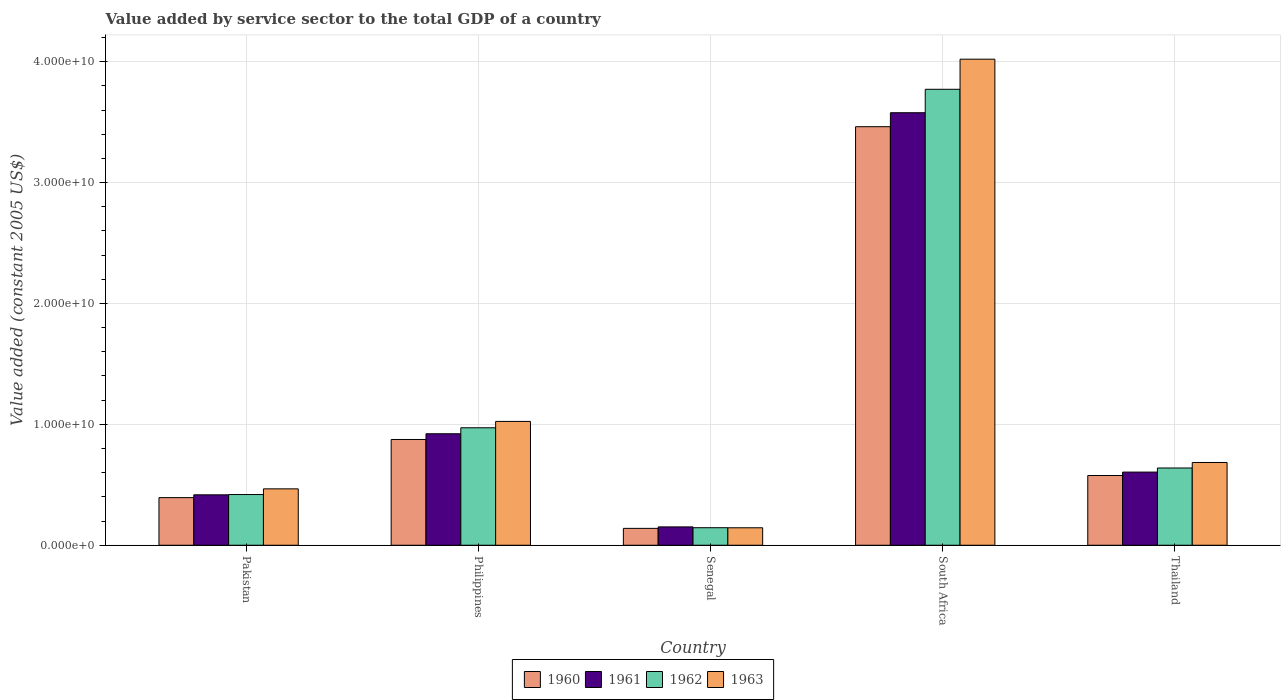Are the number of bars per tick equal to the number of legend labels?
Ensure brevity in your answer.  Yes. How many bars are there on the 4th tick from the left?
Your answer should be very brief. 4. How many bars are there on the 1st tick from the right?
Provide a succinct answer. 4. What is the label of the 5th group of bars from the left?
Offer a terse response. Thailand. In how many cases, is the number of bars for a given country not equal to the number of legend labels?
Ensure brevity in your answer.  0. What is the value added by service sector in 1962 in South Africa?
Provide a succinct answer. 3.77e+1. Across all countries, what is the maximum value added by service sector in 1961?
Give a very brief answer. 3.58e+1. Across all countries, what is the minimum value added by service sector in 1963?
Your answer should be very brief. 1.44e+09. In which country was the value added by service sector in 1960 maximum?
Your response must be concise. South Africa. In which country was the value added by service sector in 1963 minimum?
Make the answer very short. Senegal. What is the total value added by service sector in 1963 in the graph?
Offer a very short reply. 6.34e+1. What is the difference between the value added by service sector in 1962 in Philippines and that in Senegal?
Your answer should be very brief. 8.27e+09. What is the difference between the value added by service sector in 1963 in Pakistan and the value added by service sector in 1960 in South Africa?
Keep it short and to the point. -3.00e+1. What is the average value added by service sector in 1960 per country?
Your answer should be very brief. 1.09e+1. What is the difference between the value added by service sector of/in 1960 and value added by service sector of/in 1963 in Philippines?
Your response must be concise. -1.49e+09. What is the ratio of the value added by service sector in 1963 in Pakistan to that in Senegal?
Your response must be concise. 3.23. Is the difference between the value added by service sector in 1960 in Senegal and South Africa greater than the difference between the value added by service sector in 1963 in Senegal and South Africa?
Your answer should be very brief. Yes. What is the difference between the highest and the second highest value added by service sector in 1962?
Ensure brevity in your answer.  -2.80e+1. What is the difference between the highest and the lowest value added by service sector in 1962?
Ensure brevity in your answer.  3.63e+1. In how many countries, is the value added by service sector in 1962 greater than the average value added by service sector in 1962 taken over all countries?
Make the answer very short. 1. Is the sum of the value added by service sector in 1960 in Pakistan and Thailand greater than the maximum value added by service sector in 1962 across all countries?
Your answer should be compact. No. What does the 2nd bar from the left in Philippines represents?
Your response must be concise. 1961. Is it the case that in every country, the sum of the value added by service sector in 1961 and value added by service sector in 1963 is greater than the value added by service sector in 1962?
Make the answer very short. Yes. How many countries are there in the graph?
Make the answer very short. 5. Where does the legend appear in the graph?
Your answer should be compact. Bottom center. How many legend labels are there?
Keep it short and to the point. 4. What is the title of the graph?
Ensure brevity in your answer.  Value added by service sector to the total GDP of a country. Does "1971" appear as one of the legend labels in the graph?
Provide a succinct answer. No. What is the label or title of the X-axis?
Provide a short and direct response. Country. What is the label or title of the Y-axis?
Provide a succinct answer. Value added (constant 2005 US$). What is the Value added (constant 2005 US$) of 1960 in Pakistan?
Your response must be concise. 3.94e+09. What is the Value added (constant 2005 US$) of 1961 in Pakistan?
Give a very brief answer. 4.17e+09. What is the Value added (constant 2005 US$) of 1962 in Pakistan?
Your response must be concise. 4.19e+09. What is the Value added (constant 2005 US$) in 1963 in Pakistan?
Provide a short and direct response. 4.66e+09. What is the Value added (constant 2005 US$) of 1960 in Philippines?
Offer a very short reply. 8.75e+09. What is the Value added (constant 2005 US$) of 1961 in Philippines?
Your response must be concise. 9.22e+09. What is the Value added (constant 2005 US$) of 1962 in Philippines?
Your response must be concise. 9.72e+09. What is the Value added (constant 2005 US$) of 1963 in Philippines?
Make the answer very short. 1.02e+1. What is the Value added (constant 2005 US$) in 1960 in Senegal?
Provide a short and direct response. 1.39e+09. What is the Value added (constant 2005 US$) in 1961 in Senegal?
Your answer should be compact. 1.52e+09. What is the Value added (constant 2005 US$) in 1962 in Senegal?
Your answer should be compact. 1.45e+09. What is the Value added (constant 2005 US$) of 1963 in Senegal?
Keep it short and to the point. 1.44e+09. What is the Value added (constant 2005 US$) in 1960 in South Africa?
Make the answer very short. 3.46e+1. What is the Value added (constant 2005 US$) of 1961 in South Africa?
Give a very brief answer. 3.58e+1. What is the Value added (constant 2005 US$) of 1962 in South Africa?
Offer a terse response. 3.77e+1. What is the Value added (constant 2005 US$) in 1963 in South Africa?
Keep it short and to the point. 4.02e+1. What is the Value added (constant 2005 US$) of 1960 in Thailand?
Provide a short and direct response. 5.77e+09. What is the Value added (constant 2005 US$) of 1961 in Thailand?
Your response must be concise. 6.05e+09. What is the Value added (constant 2005 US$) of 1962 in Thailand?
Your answer should be compact. 6.39e+09. What is the Value added (constant 2005 US$) of 1963 in Thailand?
Offer a terse response. 6.84e+09. Across all countries, what is the maximum Value added (constant 2005 US$) of 1960?
Your answer should be very brief. 3.46e+1. Across all countries, what is the maximum Value added (constant 2005 US$) of 1961?
Your response must be concise. 3.58e+1. Across all countries, what is the maximum Value added (constant 2005 US$) of 1962?
Provide a succinct answer. 3.77e+1. Across all countries, what is the maximum Value added (constant 2005 US$) of 1963?
Ensure brevity in your answer.  4.02e+1. Across all countries, what is the minimum Value added (constant 2005 US$) in 1960?
Your answer should be very brief. 1.39e+09. Across all countries, what is the minimum Value added (constant 2005 US$) in 1961?
Make the answer very short. 1.52e+09. Across all countries, what is the minimum Value added (constant 2005 US$) of 1962?
Ensure brevity in your answer.  1.45e+09. Across all countries, what is the minimum Value added (constant 2005 US$) of 1963?
Offer a terse response. 1.44e+09. What is the total Value added (constant 2005 US$) in 1960 in the graph?
Your answer should be compact. 5.45e+1. What is the total Value added (constant 2005 US$) of 1961 in the graph?
Your answer should be very brief. 5.67e+1. What is the total Value added (constant 2005 US$) of 1962 in the graph?
Your answer should be compact. 5.95e+1. What is the total Value added (constant 2005 US$) of 1963 in the graph?
Ensure brevity in your answer.  6.34e+1. What is the difference between the Value added (constant 2005 US$) of 1960 in Pakistan and that in Philippines?
Your response must be concise. -4.81e+09. What is the difference between the Value added (constant 2005 US$) of 1961 in Pakistan and that in Philippines?
Offer a terse response. -5.05e+09. What is the difference between the Value added (constant 2005 US$) of 1962 in Pakistan and that in Philippines?
Provide a short and direct response. -5.52e+09. What is the difference between the Value added (constant 2005 US$) in 1963 in Pakistan and that in Philippines?
Provide a succinct answer. -5.58e+09. What is the difference between the Value added (constant 2005 US$) in 1960 in Pakistan and that in Senegal?
Ensure brevity in your answer.  2.54e+09. What is the difference between the Value added (constant 2005 US$) in 1961 in Pakistan and that in Senegal?
Your answer should be compact. 2.65e+09. What is the difference between the Value added (constant 2005 US$) of 1962 in Pakistan and that in Senegal?
Give a very brief answer. 2.74e+09. What is the difference between the Value added (constant 2005 US$) of 1963 in Pakistan and that in Senegal?
Give a very brief answer. 3.22e+09. What is the difference between the Value added (constant 2005 US$) in 1960 in Pakistan and that in South Africa?
Offer a very short reply. -3.07e+1. What is the difference between the Value added (constant 2005 US$) of 1961 in Pakistan and that in South Africa?
Make the answer very short. -3.16e+1. What is the difference between the Value added (constant 2005 US$) of 1962 in Pakistan and that in South Africa?
Ensure brevity in your answer.  -3.35e+1. What is the difference between the Value added (constant 2005 US$) of 1963 in Pakistan and that in South Africa?
Offer a very short reply. -3.55e+1. What is the difference between the Value added (constant 2005 US$) in 1960 in Pakistan and that in Thailand?
Provide a short and direct response. -1.83e+09. What is the difference between the Value added (constant 2005 US$) in 1961 in Pakistan and that in Thailand?
Your answer should be compact. -1.88e+09. What is the difference between the Value added (constant 2005 US$) of 1962 in Pakistan and that in Thailand?
Ensure brevity in your answer.  -2.20e+09. What is the difference between the Value added (constant 2005 US$) in 1963 in Pakistan and that in Thailand?
Ensure brevity in your answer.  -2.18e+09. What is the difference between the Value added (constant 2005 US$) of 1960 in Philippines and that in Senegal?
Provide a succinct answer. 7.35e+09. What is the difference between the Value added (constant 2005 US$) of 1961 in Philippines and that in Senegal?
Keep it short and to the point. 7.70e+09. What is the difference between the Value added (constant 2005 US$) of 1962 in Philippines and that in Senegal?
Offer a very short reply. 8.27e+09. What is the difference between the Value added (constant 2005 US$) of 1963 in Philippines and that in Senegal?
Keep it short and to the point. 8.80e+09. What is the difference between the Value added (constant 2005 US$) of 1960 in Philippines and that in South Africa?
Your response must be concise. -2.59e+1. What is the difference between the Value added (constant 2005 US$) in 1961 in Philippines and that in South Africa?
Your answer should be compact. -2.66e+1. What is the difference between the Value added (constant 2005 US$) of 1962 in Philippines and that in South Africa?
Offer a terse response. -2.80e+1. What is the difference between the Value added (constant 2005 US$) of 1963 in Philippines and that in South Africa?
Give a very brief answer. -3.00e+1. What is the difference between the Value added (constant 2005 US$) of 1960 in Philippines and that in Thailand?
Keep it short and to the point. 2.98e+09. What is the difference between the Value added (constant 2005 US$) of 1961 in Philippines and that in Thailand?
Offer a very short reply. 3.17e+09. What is the difference between the Value added (constant 2005 US$) in 1962 in Philippines and that in Thailand?
Keep it short and to the point. 3.33e+09. What is the difference between the Value added (constant 2005 US$) of 1963 in Philippines and that in Thailand?
Offer a terse response. 3.40e+09. What is the difference between the Value added (constant 2005 US$) in 1960 in Senegal and that in South Africa?
Make the answer very short. -3.32e+1. What is the difference between the Value added (constant 2005 US$) of 1961 in Senegal and that in South Africa?
Make the answer very short. -3.43e+1. What is the difference between the Value added (constant 2005 US$) of 1962 in Senegal and that in South Africa?
Provide a short and direct response. -3.63e+1. What is the difference between the Value added (constant 2005 US$) of 1963 in Senegal and that in South Africa?
Your answer should be very brief. -3.88e+1. What is the difference between the Value added (constant 2005 US$) of 1960 in Senegal and that in Thailand?
Ensure brevity in your answer.  -4.37e+09. What is the difference between the Value added (constant 2005 US$) in 1961 in Senegal and that in Thailand?
Keep it short and to the point. -4.53e+09. What is the difference between the Value added (constant 2005 US$) in 1962 in Senegal and that in Thailand?
Provide a short and direct response. -4.94e+09. What is the difference between the Value added (constant 2005 US$) in 1963 in Senegal and that in Thailand?
Ensure brevity in your answer.  -5.40e+09. What is the difference between the Value added (constant 2005 US$) of 1960 in South Africa and that in Thailand?
Offer a terse response. 2.89e+1. What is the difference between the Value added (constant 2005 US$) in 1961 in South Africa and that in Thailand?
Offer a terse response. 2.97e+1. What is the difference between the Value added (constant 2005 US$) in 1962 in South Africa and that in Thailand?
Offer a terse response. 3.13e+1. What is the difference between the Value added (constant 2005 US$) of 1963 in South Africa and that in Thailand?
Offer a very short reply. 3.34e+1. What is the difference between the Value added (constant 2005 US$) in 1960 in Pakistan and the Value added (constant 2005 US$) in 1961 in Philippines?
Give a very brief answer. -5.28e+09. What is the difference between the Value added (constant 2005 US$) of 1960 in Pakistan and the Value added (constant 2005 US$) of 1962 in Philippines?
Provide a succinct answer. -5.78e+09. What is the difference between the Value added (constant 2005 US$) of 1960 in Pakistan and the Value added (constant 2005 US$) of 1963 in Philippines?
Ensure brevity in your answer.  -6.30e+09. What is the difference between the Value added (constant 2005 US$) of 1961 in Pakistan and the Value added (constant 2005 US$) of 1962 in Philippines?
Provide a short and direct response. -5.55e+09. What is the difference between the Value added (constant 2005 US$) in 1961 in Pakistan and the Value added (constant 2005 US$) in 1963 in Philippines?
Your response must be concise. -6.07e+09. What is the difference between the Value added (constant 2005 US$) of 1962 in Pakistan and the Value added (constant 2005 US$) of 1963 in Philippines?
Your response must be concise. -6.05e+09. What is the difference between the Value added (constant 2005 US$) in 1960 in Pakistan and the Value added (constant 2005 US$) in 1961 in Senegal?
Offer a terse response. 2.42e+09. What is the difference between the Value added (constant 2005 US$) in 1960 in Pakistan and the Value added (constant 2005 US$) in 1962 in Senegal?
Provide a succinct answer. 2.49e+09. What is the difference between the Value added (constant 2005 US$) in 1960 in Pakistan and the Value added (constant 2005 US$) in 1963 in Senegal?
Provide a succinct answer. 2.49e+09. What is the difference between the Value added (constant 2005 US$) of 1961 in Pakistan and the Value added (constant 2005 US$) of 1962 in Senegal?
Ensure brevity in your answer.  2.72e+09. What is the difference between the Value added (constant 2005 US$) in 1961 in Pakistan and the Value added (constant 2005 US$) in 1963 in Senegal?
Offer a terse response. 2.73e+09. What is the difference between the Value added (constant 2005 US$) in 1962 in Pakistan and the Value added (constant 2005 US$) in 1963 in Senegal?
Provide a succinct answer. 2.75e+09. What is the difference between the Value added (constant 2005 US$) of 1960 in Pakistan and the Value added (constant 2005 US$) of 1961 in South Africa?
Your answer should be very brief. -3.18e+1. What is the difference between the Value added (constant 2005 US$) in 1960 in Pakistan and the Value added (constant 2005 US$) in 1962 in South Africa?
Keep it short and to the point. -3.38e+1. What is the difference between the Value added (constant 2005 US$) in 1960 in Pakistan and the Value added (constant 2005 US$) in 1963 in South Africa?
Give a very brief answer. -3.63e+1. What is the difference between the Value added (constant 2005 US$) in 1961 in Pakistan and the Value added (constant 2005 US$) in 1962 in South Africa?
Your response must be concise. -3.35e+1. What is the difference between the Value added (constant 2005 US$) of 1961 in Pakistan and the Value added (constant 2005 US$) of 1963 in South Africa?
Ensure brevity in your answer.  -3.60e+1. What is the difference between the Value added (constant 2005 US$) of 1962 in Pakistan and the Value added (constant 2005 US$) of 1963 in South Africa?
Give a very brief answer. -3.60e+1. What is the difference between the Value added (constant 2005 US$) of 1960 in Pakistan and the Value added (constant 2005 US$) of 1961 in Thailand?
Ensure brevity in your answer.  -2.11e+09. What is the difference between the Value added (constant 2005 US$) in 1960 in Pakistan and the Value added (constant 2005 US$) in 1962 in Thailand?
Provide a short and direct response. -2.45e+09. What is the difference between the Value added (constant 2005 US$) of 1960 in Pakistan and the Value added (constant 2005 US$) of 1963 in Thailand?
Your answer should be very brief. -2.91e+09. What is the difference between the Value added (constant 2005 US$) of 1961 in Pakistan and the Value added (constant 2005 US$) of 1962 in Thailand?
Ensure brevity in your answer.  -2.22e+09. What is the difference between the Value added (constant 2005 US$) in 1961 in Pakistan and the Value added (constant 2005 US$) in 1963 in Thailand?
Provide a short and direct response. -2.67e+09. What is the difference between the Value added (constant 2005 US$) of 1962 in Pakistan and the Value added (constant 2005 US$) of 1963 in Thailand?
Your response must be concise. -2.65e+09. What is the difference between the Value added (constant 2005 US$) in 1960 in Philippines and the Value added (constant 2005 US$) in 1961 in Senegal?
Provide a succinct answer. 7.23e+09. What is the difference between the Value added (constant 2005 US$) of 1960 in Philippines and the Value added (constant 2005 US$) of 1962 in Senegal?
Your answer should be compact. 7.30e+09. What is the difference between the Value added (constant 2005 US$) in 1960 in Philippines and the Value added (constant 2005 US$) in 1963 in Senegal?
Ensure brevity in your answer.  7.30e+09. What is the difference between the Value added (constant 2005 US$) in 1961 in Philippines and the Value added (constant 2005 US$) in 1962 in Senegal?
Offer a very short reply. 7.77e+09. What is the difference between the Value added (constant 2005 US$) in 1961 in Philippines and the Value added (constant 2005 US$) in 1963 in Senegal?
Provide a short and direct response. 7.78e+09. What is the difference between the Value added (constant 2005 US$) in 1962 in Philippines and the Value added (constant 2005 US$) in 1963 in Senegal?
Keep it short and to the point. 8.27e+09. What is the difference between the Value added (constant 2005 US$) in 1960 in Philippines and the Value added (constant 2005 US$) in 1961 in South Africa?
Your answer should be compact. -2.70e+1. What is the difference between the Value added (constant 2005 US$) of 1960 in Philippines and the Value added (constant 2005 US$) of 1962 in South Africa?
Your response must be concise. -2.90e+1. What is the difference between the Value added (constant 2005 US$) in 1960 in Philippines and the Value added (constant 2005 US$) in 1963 in South Africa?
Keep it short and to the point. -3.15e+1. What is the difference between the Value added (constant 2005 US$) of 1961 in Philippines and the Value added (constant 2005 US$) of 1962 in South Africa?
Your response must be concise. -2.85e+1. What is the difference between the Value added (constant 2005 US$) in 1961 in Philippines and the Value added (constant 2005 US$) in 1963 in South Africa?
Offer a very short reply. -3.10e+1. What is the difference between the Value added (constant 2005 US$) of 1962 in Philippines and the Value added (constant 2005 US$) of 1963 in South Africa?
Keep it short and to the point. -3.05e+1. What is the difference between the Value added (constant 2005 US$) of 1960 in Philippines and the Value added (constant 2005 US$) of 1961 in Thailand?
Offer a very short reply. 2.70e+09. What is the difference between the Value added (constant 2005 US$) of 1960 in Philippines and the Value added (constant 2005 US$) of 1962 in Thailand?
Offer a terse response. 2.36e+09. What is the difference between the Value added (constant 2005 US$) of 1960 in Philippines and the Value added (constant 2005 US$) of 1963 in Thailand?
Your response must be concise. 1.90e+09. What is the difference between the Value added (constant 2005 US$) of 1961 in Philippines and the Value added (constant 2005 US$) of 1962 in Thailand?
Offer a terse response. 2.83e+09. What is the difference between the Value added (constant 2005 US$) in 1961 in Philippines and the Value added (constant 2005 US$) in 1963 in Thailand?
Your response must be concise. 2.38e+09. What is the difference between the Value added (constant 2005 US$) in 1962 in Philippines and the Value added (constant 2005 US$) in 1963 in Thailand?
Provide a short and direct response. 2.87e+09. What is the difference between the Value added (constant 2005 US$) of 1960 in Senegal and the Value added (constant 2005 US$) of 1961 in South Africa?
Your response must be concise. -3.44e+1. What is the difference between the Value added (constant 2005 US$) of 1960 in Senegal and the Value added (constant 2005 US$) of 1962 in South Africa?
Provide a short and direct response. -3.63e+1. What is the difference between the Value added (constant 2005 US$) in 1960 in Senegal and the Value added (constant 2005 US$) in 1963 in South Africa?
Your answer should be very brief. -3.88e+1. What is the difference between the Value added (constant 2005 US$) in 1961 in Senegal and the Value added (constant 2005 US$) in 1962 in South Africa?
Provide a short and direct response. -3.62e+1. What is the difference between the Value added (constant 2005 US$) of 1961 in Senegal and the Value added (constant 2005 US$) of 1963 in South Africa?
Your response must be concise. -3.87e+1. What is the difference between the Value added (constant 2005 US$) of 1962 in Senegal and the Value added (constant 2005 US$) of 1963 in South Africa?
Offer a terse response. -3.88e+1. What is the difference between the Value added (constant 2005 US$) in 1960 in Senegal and the Value added (constant 2005 US$) in 1961 in Thailand?
Offer a terse response. -4.66e+09. What is the difference between the Value added (constant 2005 US$) in 1960 in Senegal and the Value added (constant 2005 US$) in 1962 in Thailand?
Keep it short and to the point. -5.00e+09. What is the difference between the Value added (constant 2005 US$) in 1960 in Senegal and the Value added (constant 2005 US$) in 1963 in Thailand?
Your response must be concise. -5.45e+09. What is the difference between the Value added (constant 2005 US$) of 1961 in Senegal and the Value added (constant 2005 US$) of 1962 in Thailand?
Ensure brevity in your answer.  -4.87e+09. What is the difference between the Value added (constant 2005 US$) in 1961 in Senegal and the Value added (constant 2005 US$) in 1963 in Thailand?
Your response must be concise. -5.33e+09. What is the difference between the Value added (constant 2005 US$) of 1962 in Senegal and the Value added (constant 2005 US$) of 1963 in Thailand?
Offer a terse response. -5.39e+09. What is the difference between the Value added (constant 2005 US$) of 1960 in South Africa and the Value added (constant 2005 US$) of 1961 in Thailand?
Offer a terse response. 2.86e+1. What is the difference between the Value added (constant 2005 US$) in 1960 in South Africa and the Value added (constant 2005 US$) in 1962 in Thailand?
Provide a succinct answer. 2.82e+1. What is the difference between the Value added (constant 2005 US$) in 1960 in South Africa and the Value added (constant 2005 US$) in 1963 in Thailand?
Ensure brevity in your answer.  2.78e+1. What is the difference between the Value added (constant 2005 US$) of 1961 in South Africa and the Value added (constant 2005 US$) of 1962 in Thailand?
Provide a short and direct response. 2.94e+1. What is the difference between the Value added (constant 2005 US$) in 1961 in South Africa and the Value added (constant 2005 US$) in 1963 in Thailand?
Provide a succinct answer. 2.89e+1. What is the difference between the Value added (constant 2005 US$) in 1962 in South Africa and the Value added (constant 2005 US$) in 1963 in Thailand?
Provide a short and direct response. 3.09e+1. What is the average Value added (constant 2005 US$) of 1960 per country?
Your response must be concise. 1.09e+1. What is the average Value added (constant 2005 US$) of 1961 per country?
Offer a terse response. 1.13e+1. What is the average Value added (constant 2005 US$) in 1962 per country?
Ensure brevity in your answer.  1.19e+1. What is the average Value added (constant 2005 US$) of 1963 per country?
Provide a short and direct response. 1.27e+1. What is the difference between the Value added (constant 2005 US$) in 1960 and Value added (constant 2005 US$) in 1961 in Pakistan?
Offer a terse response. -2.32e+08. What is the difference between the Value added (constant 2005 US$) of 1960 and Value added (constant 2005 US$) of 1962 in Pakistan?
Ensure brevity in your answer.  -2.54e+08. What is the difference between the Value added (constant 2005 US$) in 1960 and Value added (constant 2005 US$) in 1963 in Pakistan?
Keep it short and to the point. -7.25e+08. What is the difference between the Value added (constant 2005 US$) in 1961 and Value added (constant 2005 US$) in 1962 in Pakistan?
Give a very brief answer. -2.26e+07. What is the difference between the Value added (constant 2005 US$) in 1961 and Value added (constant 2005 US$) in 1963 in Pakistan?
Keep it short and to the point. -4.93e+08. What is the difference between the Value added (constant 2005 US$) of 1962 and Value added (constant 2005 US$) of 1963 in Pakistan?
Ensure brevity in your answer.  -4.71e+08. What is the difference between the Value added (constant 2005 US$) of 1960 and Value added (constant 2005 US$) of 1961 in Philippines?
Your answer should be very brief. -4.73e+08. What is the difference between the Value added (constant 2005 US$) in 1960 and Value added (constant 2005 US$) in 1962 in Philippines?
Your answer should be very brief. -9.68e+08. What is the difference between the Value added (constant 2005 US$) in 1960 and Value added (constant 2005 US$) in 1963 in Philippines?
Keep it short and to the point. -1.49e+09. What is the difference between the Value added (constant 2005 US$) of 1961 and Value added (constant 2005 US$) of 1962 in Philippines?
Provide a short and direct response. -4.95e+08. What is the difference between the Value added (constant 2005 US$) in 1961 and Value added (constant 2005 US$) in 1963 in Philippines?
Your response must be concise. -1.02e+09. What is the difference between the Value added (constant 2005 US$) in 1962 and Value added (constant 2005 US$) in 1963 in Philippines?
Provide a succinct answer. -5.27e+08. What is the difference between the Value added (constant 2005 US$) of 1960 and Value added (constant 2005 US$) of 1961 in Senegal?
Your answer should be very brief. -1.22e+08. What is the difference between the Value added (constant 2005 US$) in 1960 and Value added (constant 2005 US$) in 1962 in Senegal?
Your answer should be compact. -5.52e+07. What is the difference between the Value added (constant 2005 US$) in 1960 and Value added (constant 2005 US$) in 1963 in Senegal?
Offer a very short reply. -4.94e+07. What is the difference between the Value added (constant 2005 US$) in 1961 and Value added (constant 2005 US$) in 1962 in Senegal?
Your answer should be compact. 6.67e+07. What is the difference between the Value added (constant 2005 US$) in 1961 and Value added (constant 2005 US$) in 1963 in Senegal?
Make the answer very short. 7.25e+07. What is the difference between the Value added (constant 2005 US$) in 1962 and Value added (constant 2005 US$) in 1963 in Senegal?
Offer a very short reply. 5.77e+06. What is the difference between the Value added (constant 2005 US$) in 1960 and Value added (constant 2005 US$) in 1961 in South Africa?
Your answer should be very brief. -1.16e+09. What is the difference between the Value added (constant 2005 US$) in 1960 and Value added (constant 2005 US$) in 1962 in South Africa?
Provide a succinct answer. -3.09e+09. What is the difference between the Value added (constant 2005 US$) in 1960 and Value added (constant 2005 US$) in 1963 in South Africa?
Keep it short and to the point. -5.58e+09. What is the difference between the Value added (constant 2005 US$) of 1961 and Value added (constant 2005 US$) of 1962 in South Africa?
Give a very brief answer. -1.94e+09. What is the difference between the Value added (constant 2005 US$) in 1961 and Value added (constant 2005 US$) in 1963 in South Africa?
Keep it short and to the point. -4.43e+09. What is the difference between the Value added (constant 2005 US$) in 1962 and Value added (constant 2005 US$) in 1963 in South Africa?
Your response must be concise. -2.49e+09. What is the difference between the Value added (constant 2005 US$) of 1960 and Value added (constant 2005 US$) of 1961 in Thailand?
Offer a terse response. -2.83e+08. What is the difference between the Value added (constant 2005 US$) of 1960 and Value added (constant 2005 US$) of 1962 in Thailand?
Provide a short and direct response. -6.21e+08. What is the difference between the Value added (constant 2005 US$) in 1960 and Value added (constant 2005 US$) in 1963 in Thailand?
Provide a short and direct response. -1.08e+09. What is the difference between the Value added (constant 2005 US$) of 1961 and Value added (constant 2005 US$) of 1962 in Thailand?
Provide a succinct answer. -3.39e+08. What is the difference between the Value added (constant 2005 US$) in 1961 and Value added (constant 2005 US$) in 1963 in Thailand?
Make the answer very short. -7.93e+08. What is the difference between the Value added (constant 2005 US$) of 1962 and Value added (constant 2005 US$) of 1963 in Thailand?
Provide a succinct answer. -4.54e+08. What is the ratio of the Value added (constant 2005 US$) of 1960 in Pakistan to that in Philippines?
Keep it short and to the point. 0.45. What is the ratio of the Value added (constant 2005 US$) of 1961 in Pakistan to that in Philippines?
Ensure brevity in your answer.  0.45. What is the ratio of the Value added (constant 2005 US$) of 1962 in Pakistan to that in Philippines?
Offer a terse response. 0.43. What is the ratio of the Value added (constant 2005 US$) of 1963 in Pakistan to that in Philippines?
Ensure brevity in your answer.  0.46. What is the ratio of the Value added (constant 2005 US$) of 1960 in Pakistan to that in Senegal?
Offer a very short reply. 2.82. What is the ratio of the Value added (constant 2005 US$) in 1961 in Pakistan to that in Senegal?
Give a very brief answer. 2.75. What is the ratio of the Value added (constant 2005 US$) in 1962 in Pakistan to that in Senegal?
Your answer should be very brief. 2.89. What is the ratio of the Value added (constant 2005 US$) in 1963 in Pakistan to that in Senegal?
Offer a very short reply. 3.23. What is the ratio of the Value added (constant 2005 US$) of 1960 in Pakistan to that in South Africa?
Provide a succinct answer. 0.11. What is the ratio of the Value added (constant 2005 US$) of 1961 in Pakistan to that in South Africa?
Keep it short and to the point. 0.12. What is the ratio of the Value added (constant 2005 US$) in 1962 in Pakistan to that in South Africa?
Your response must be concise. 0.11. What is the ratio of the Value added (constant 2005 US$) of 1963 in Pakistan to that in South Africa?
Provide a short and direct response. 0.12. What is the ratio of the Value added (constant 2005 US$) of 1960 in Pakistan to that in Thailand?
Make the answer very short. 0.68. What is the ratio of the Value added (constant 2005 US$) of 1961 in Pakistan to that in Thailand?
Your answer should be very brief. 0.69. What is the ratio of the Value added (constant 2005 US$) of 1962 in Pakistan to that in Thailand?
Provide a short and direct response. 0.66. What is the ratio of the Value added (constant 2005 US$) of 1963 in Pakistan to that in Thailand?
Your answer should be compact. 0.68. What is the ratio of the Value added (constant 2005 US$) in 1960 in Philippines to that in Senegal?
Provide a short and direct response. 6.27. What is the ratio of the Value added (constant 2005 US$) in 1961 in Philippines to that in Senegal?
Provide a succinct answer. 6.08. What is the ratio of the Value added (constant 2005 US$) in 1962 in Philippines to that in Senegal?
Your response must be concise. 6.7. What is the ratio of the Value added (constant 2005 US$) of 1963 in Philippines to that in Senegal?
Ensure brevity in your answer.  7.09. What is the ratio of the Value added (constant 2005 US$) of 1960 in Philippines to that in South Africa?
Give a very brief answer. 0.25. What is the ratio of the Value added (constant 2005 US$) in 1961 in Philippines to that in South Africa?
Keep it short and to the point. 0.26. What is the ratio of the Value added (constant 2005 US$) of 1962 in Philippines to that in South Africa?
Offer a terse response. 0.26. What is the ratio of the Value added (constant 2005 US$) in 1963 in Philippines to that in South Africa?
Your answer should be very brief. 0.25. What is the ratio of the Value added (constant 2005 US$) in 1960 in Philippines to that in Thailand?
Provide a succinct answer. 1.52. What is the ratio of the Value added (constant 2005 US$) in 1961 in Philippines to that in Thailand?
Your response must be concise. 1.52. What is the ratio of the Value added (constant 2005 US$) of 1962 in Philippines to that in Thailand?
Give a very brief answer. 1.52. What is the ratio of the Value added (constant 2005 US$) of 1963 in Philippines to that in Thailand?
Your response must be concise. 1.5. What is the ratio of the Value added (constant 2005 US$) in 1960 in Senegal to that in South Africa?
Make the answer very short. 0.04. What is the ratio of the Value added (constant 2005 US$) in 1961 in Senegal to that in South Africa?
Provide a succinct answer. 0.04. What is the ratio of the Value added (constant 2005 US$) in 1962 in Senegal to that in South Africa?
Ensure brevity in your answer.  0.04. What is the ratio of the Value added (constant 2005 US$) in 1963 in Senegal to that in South Africa?
Ensure brevity in your answer.  0.04. What is the ratio of the Value added (constant 2005 US$) in 1960 in Senegal to that in Thailand?
Offer a very short reply. 0.24. What is the ratio of the Value added (constant 2005 US$) of 1961 in Senegal to that in Thailand?
Offer a terse response. 0.25. What is the ratio of the Value added (constant 2005 US$) in 1962 in Senegal to that in Thailand?
Ensure brevity in your answer.  0.23. What is the ratio of the Value added (constant 2005 US$) in 1963 in Senegal to that in Thailand?
Ensure brevity in your answer.  0.21. What is the ratio of the Value added (constant 2005 US$) in 1960 in South Africa to that in Thailand?
Your response must be concise. 6. What is the ratio of the Value added (constant 2005 US$) of 1961 in South Africa to that in Thailand?
Your response must be concise. 5.91. What is the ratio of the Value added (constant 2005 US$) in 1962 in South Africa to that in Thailand?
Provide a succinct answer. 5.9. What is the ratio of the Value added (constant 2005 US$) of 1963 in South Africa to that in Thailand?
Your answer should be very brief. 5.87. What is the difference between the highest and the second highest Value added (constant 2005 US$) of 1960?
Keep it short and to the point. 2.59e+1. What is the difference between the highest and the second highest Value added (constant 2005 US$) in 1961?
Your answer should be compact. 2.66e+1. What is the difference between the highest and the second highest Value added (constant 2005 US$) of 1962?
Provide a succinct answer. 2.80e+1. What is the difference between the highest and the second highest Value added (constant 2005 US$) in 1963?
Your response must be concise. 3.00e+1. What is the difference between the highest and the lowest Value added (constant 2005 US$) of 1960?
Give a very brief answer. 3.32e+1. What is the difference between the highest and the lowest Value added (constant 2005 US$) of 1961?
Your answer should be compact. 3.43e+1. What is the difference between the highest and the lowest Value added (constant 2005 US$) in 1962?
Give a very brief answer. 3.63e+1. What is the difference between the highest and the lowest Value added (constant 2005 US$) of 1963?
Your response must be concise. 3.88e+1. 